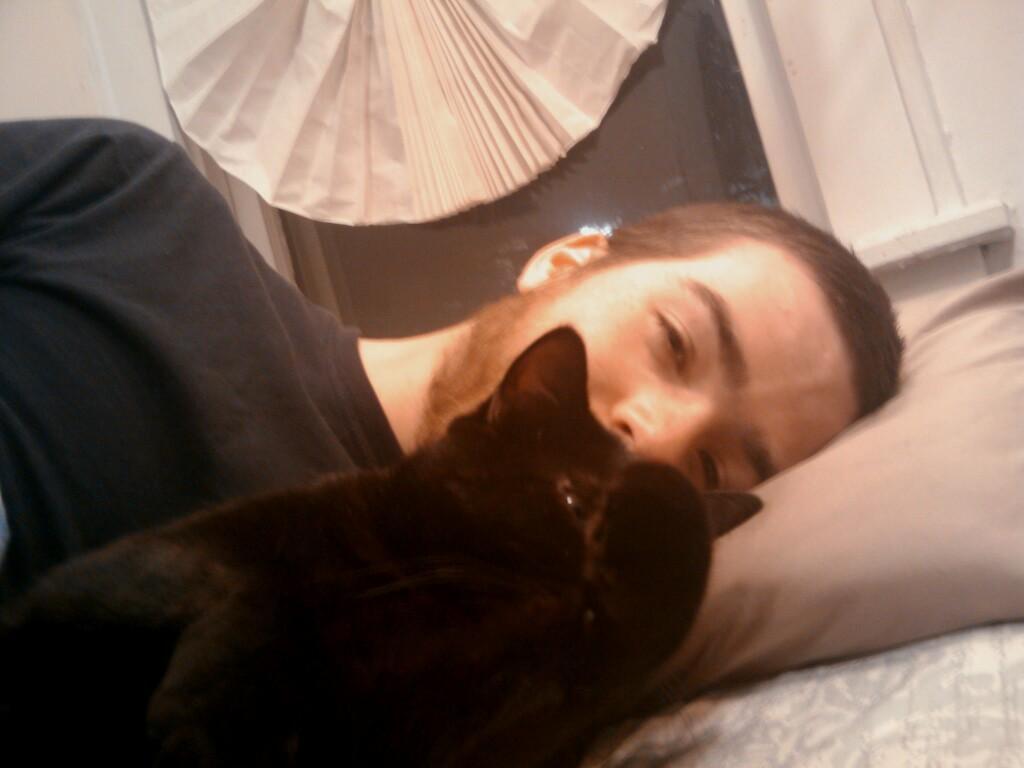How would you summarize this image in a sentence or two? In this image I can see a cat in black color, background I can see a person laying on the bed and the person is wearing black color shirt. Background the wall is in white color. 